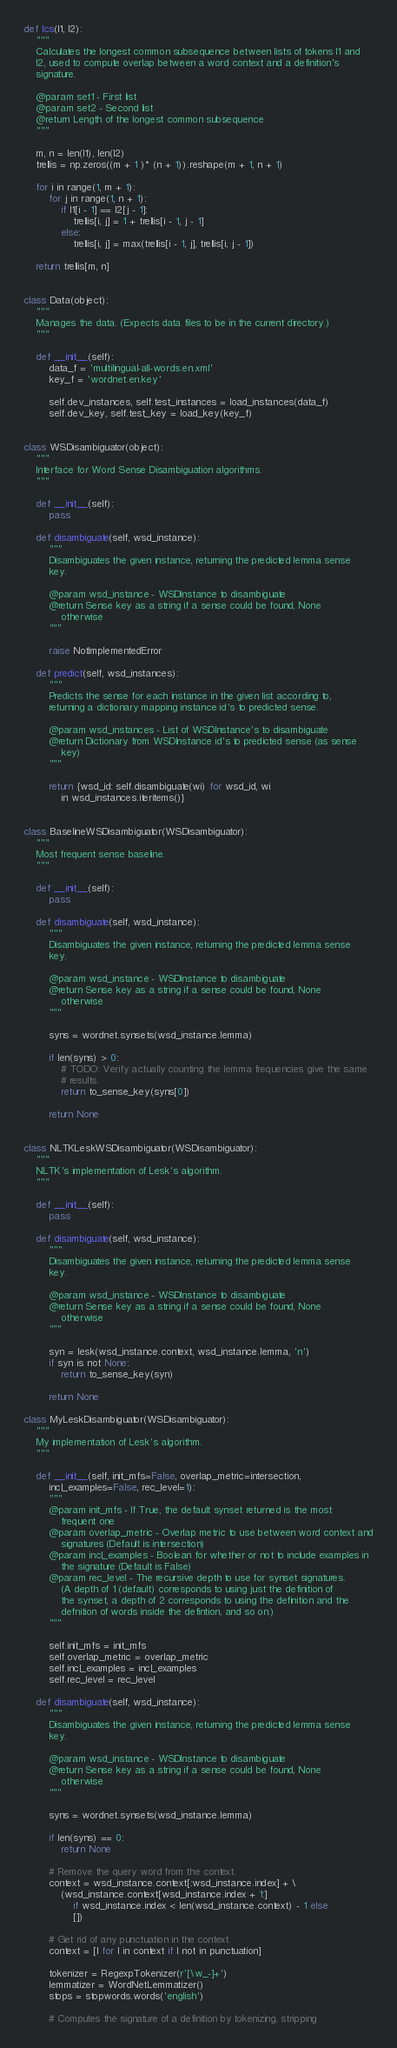<code> <loc_0><loc_0><loc_500><loc_500><_Python_>

def lcs(l1, l2):
	"""
	Calculates the longest common subsequence between lists of tokens l1 and
	l2, used to compute overlap between a word context and a definition's
	signature.

	@param set1 - First list
	@param set2 - Second list
	@return Length of the longest common subsequence
	"""

	m, n = len(l1), len(l2)
	trellis = np.zeros((m + 1 )* (n + 1)).reshape(m + 1, n + 1)

	for i in range(1, m + 1):
		for j in range(1, n + 1):
			if l1[i - 1] == l2[j - 1]:
				trellis[i, j] = 1 + trellis[i - 1, j - 1]
			else:
				trellis[i, j] = max(trellis[i - 1, j], trellis[i, j - 1])

	return trellis[m, n]


class Data(object):
	"""
	Manages the data. (Expects data files to be in the current directory.)
	"""

	def __init__(self):
		data_f = 'multilingual-all-words.en.xml'
		key_f = 'wordnet.en.key'

		self.dev_instances, self.test_instances = load_instances(data_f)
		self.dev_key, self.test_key = load_key(key_f)


class WSDisambiguator(object):
	"""
	Interface for Word Sense Disambiguation algorithms.
	"""

	def __init__(self):
		pass

	def disambiguate(self, wsd_instance):
		"""
		Disambiguates the given instance, returning the predicted lemma sense
		key.

		@param wsd_instance - WSDInstance to disambiguate
		@return Sense key as a string if a sense could be found, None
			otherwise
		"""

		raise NotImplementedError

	def predict(self, wsd_instances):
		"""
		Predicts the sense for each instance in the given list according to,
		returning a dictionary mapping instance id's to predicted sense.

		@param wsd_instances - List of WSDInstance's to disambiguate
		@return Dictionary from WSDInstance id's to predicted sense (as sense
			key)
		"""

		return {wsd_id: self.disambiguate(wi) for wsd_id, wi
			in wsd_instances.iteritems()}


class BaselineWSDisambiguator(WSDisambiguator):
	"""
	Most frequent sense baseline.
	"""

	def __init__(self):
		pass

	def disambiguate(self, wsd_instance):
		"""
		Disambiguates the given instance, returning the predicted lemma sense
		key.

		@param wsd_instance - WSDInstance to disambiguate
		@return Sense key as a string if a sense could be found, None
			otherwise
		"""

		syns = wordnet.synsets(wsd_instance.lemma)

		if len(syns) > 0:
			# TODO: Verify actually counting the lemma frequencies give the same
			# results.
			return to_sense_key(syns[0])

		return None


class NLTKLeskWSDisambiguator(WSDisambiguator):
	"""
	NLTK's implementation of Lesk's algorithm.
	"""

	def __init__(self):
		pass

	def disambiguate(self, wsd_instance):
		"""
		Disambiguates the given instance, returning the predicted lemma sense
		key.

		@param wsd_instance - WSDInstance to disambiguate
		@return Sense key as a string if a sense could be found, None
			otherwise
		"""

		syn = lesk(wsd_instance.context, wsd_instance.lemma, 'n')
		if syn is not None:
			return to_sense_key(syn)
		
		return None

class MyLeskDisambiguator(WSDisambiguator):
	"""
	My implementation of Lesk's algorithm.
	"""

	def __init__(self, init_mfs=False, overlap_metric=intersection,
		incl_examples=False, rec_level=1):
		"""
		@param init_mfs - If True, the default synset returned is the most
			frequent one
		@param overlap_metric - Overlap metric to use between word context and
			signatures (Default is intersection)
		@param incl_examples - Boolean for whether or not to include examples in
			the signature (Default is False)
		@param rec_level - The recursive depth to use for synset signatures.
			(A depth of 1 (default) corresponds to using just the definition of
			the synset, a depth of 2 corresponds to using the definition and the
			defnition of words inside the defintion, and so on.)
		"""

		self.init_mfs = init_mfs
		self.overlap_metric = overlap_metric
		self.incl_examples = incl_examples
		self.rec_level = rec_level

	def disambiguate(self, wsd_instance):
		"""
		Disambiguates the given instance, returning the predicted lemma sense
		key.

		@param wsd_instance - WSDInstance to disambiguate
		@return Sense key as a string if a sense could be found, None
			otherwise
		"""

		syns = wordnet.synsets(wsd_instance.lemma)

		if len(syns) == 0:
			return None

		# Remove the query word from the context.
		context = wsd_instance.context[:wsd_instance.index] + \
			(wsd_instance.context[wsd_instance.index + 1:]
				if wsd_instance.index < len(wsd_instance.context) - 1 else
				[])

		# Get rid of any punctuation in the context.
		context = [l for l in context if l not in punctuation]

		tokenizer = RegexpTokenizer(r'[\w_-]+')
		lemmatizer = WordNetLemmatizer()
		stops = stopwords.words('english')

		# Computes the signature of a definition by tokenizing, stripping</code> 